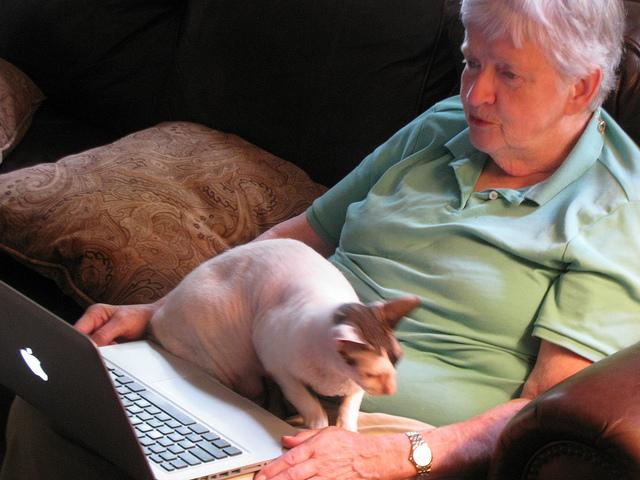Does this woman have a small dog sitting in her lap?
Quick response, please. No. Is the cat happy?
Keep it brief. Yes. What happened to the cat's fur?
Quick response, please. Shaved. 